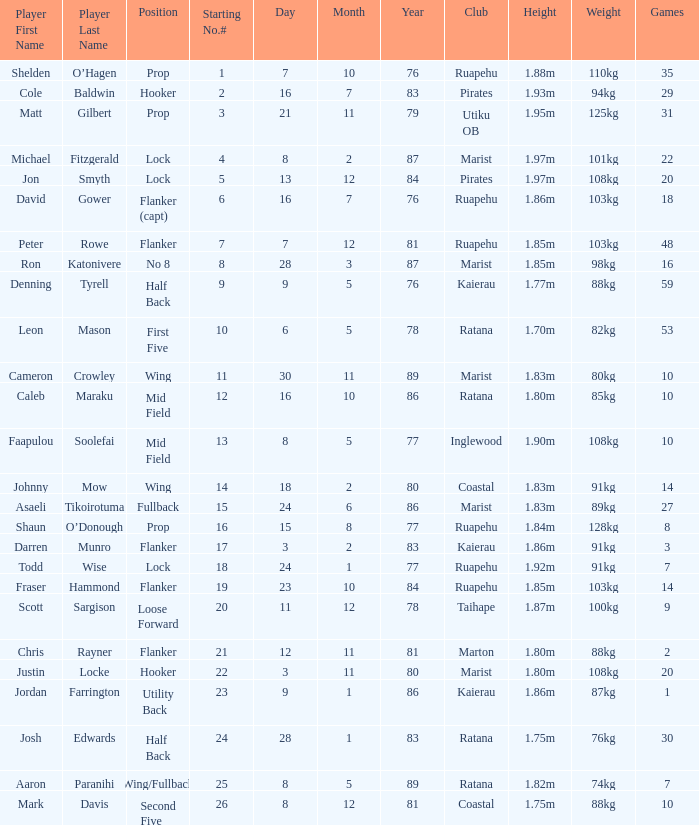How many games were played where the player's height is 1.0. 